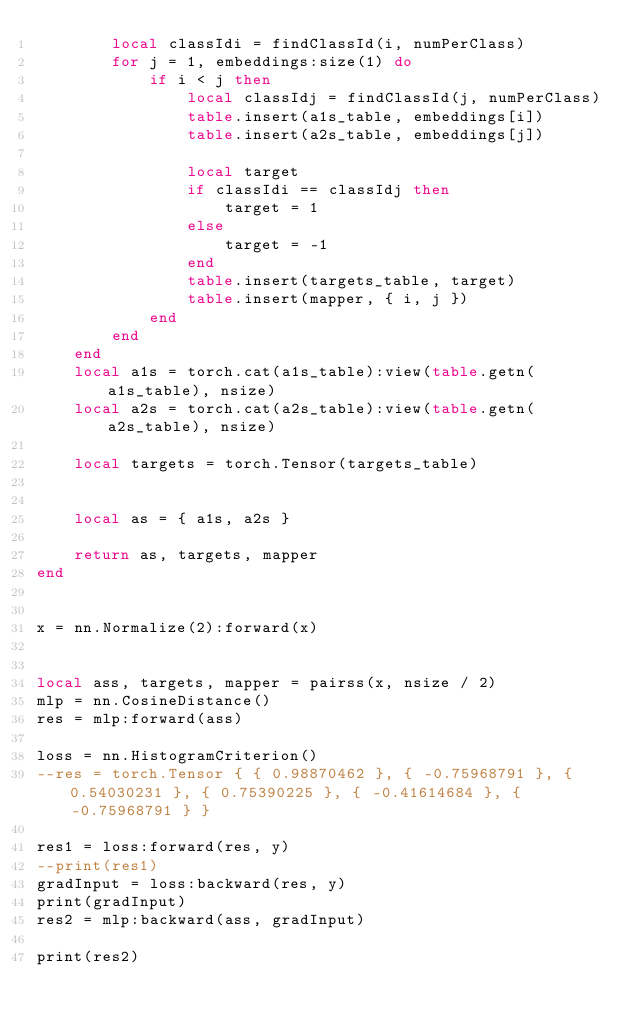<code> <loc_0><loc_0><loc_500><loc_500><_Lua_>        local classIdi = findClassId(i, numPerClass)
        for j = 1, embeddings:size(1) do
            if i < j then
                local classIdj = findClassId(j, numPerClass)
                table.insert(a1s_table, embeddings[i])
                table.insert(a2s_table, embeddings[j])

                local target
                if classIdi == classIdj then
                    target = 1
                else
                    target = -1
                end
                table.insert(targets_table, target)
                table.insert(mapper, { i, j })
            end
        end
    end
    local a1s = torch.cat(a1s_table):view(table.getn(a1s_table), nsize)
    local a2s = torch.cat(a2s_table):view(table.getn(a2s_table), nsize)

    local targets = torch.Tensor(targets_table)


    local as = { a1s, a2s }

    return as, targets, mapper
end


x = nn.Normalize(2):forward(x)


local ass, targets, mapper = pairss(x, nsize / 2)
mlp = nn.CosineDistance()
res = mlp:forward(ass)

loss = nn.HistogramCriterion()
--res = torch.Tensor { { 0.98870462 }, { -0.75968791 }, { 0.54030231 }, { 0.75390225 }, { -0.41614684 }, { -0.75968791 } }

res1 = loss:forward(res, y)
--print(res1)
gradInput = loss:backward(res, y)
print(gradInput)
res2 = mlp:backward(ass, gradInput)

print(res2)</code> 